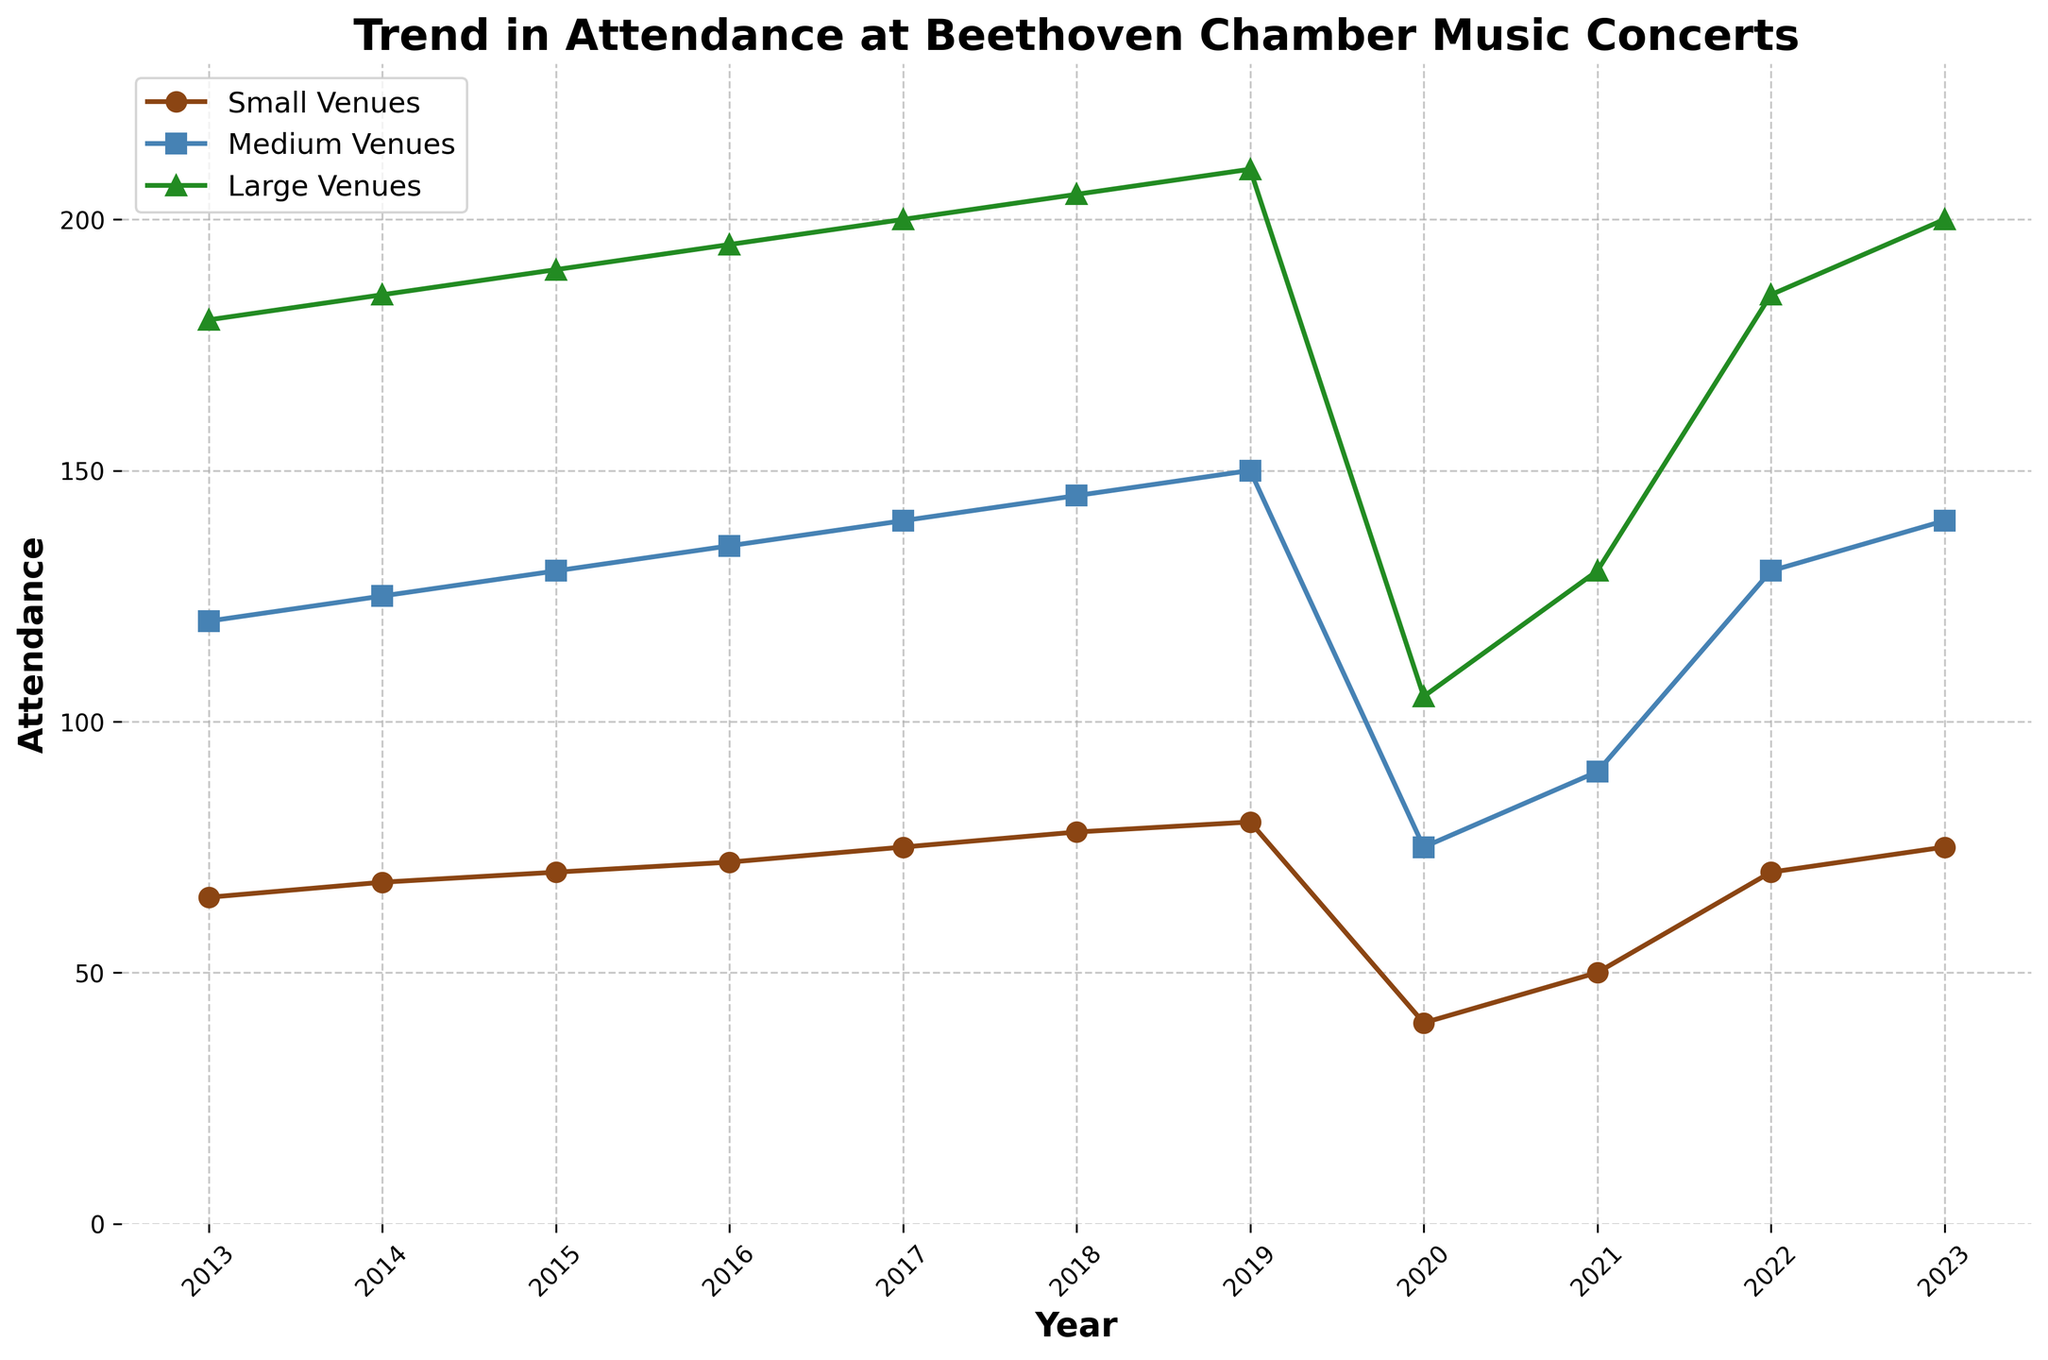Which year had the lowest attendance for large venues? To find the year with the lowest attendance for large venues, look at the line representing large venues and identify the year with the lowest point. The lowest attendance for large venues was in 2020.
Answer: 2020 What was the attendance in medium venues in 2016? Locate the year 2016 on the horizontal axis and follow it until it intersects with the line representing medium venues. The attendance was 135 in 2016.
Answer: 135 How much did attendance in small venues increase from 2013 to 2023? Subtract the attendance in small venues in 2013 from the attendance in 2023: 75 - 65 = 10.
Answer: 10 Which year saw the largest drop in attendance for small venues? Look for the steepest decline in the line representing small venues. The largest drop occurred between 2019 and 2020, from 80 to 40.
Answer: 2020 Compare the attendance in large venues in 2021 with that in medium venues in 2014. Which was higher? Compare the two attendance values: For large venues in 2021, it is 130; for medium venues in 2014, it is 125. Attendance was higher in large venues in 2021.
Answer: Large venues in 2021 In which year did all venues see an increase in attendance compared to the previous year? Check the lines for all venues to find a year where each line shows an upward trend. The year 2023 had increases in attendance for all venues compared to 2022.
Answer: 2023 What is the total attendance for medium venues across all years shown? Sum the attendance values for medium venues from 2013 to 2023: 120 + 125 + 130 + 135 + 140 + 145 + 150 + 75 + 90 + 130 + 140 = 1280.
Answer: 1280 How did the attendance in medium venues change between 2020 and 2021 in percentage terms? Calculate the percentage change: ((90 - 75) / 75) * 100 = 20%. The attendance increased by 20%.
Answer: 20% Is the trend in attendance for large venues linear over the entire period? A linear trend would show a straight-line progression. The line for large venues shows a noticeable decline in 2020, indicating that the trend is not linear over the entire period.
Answer: No 